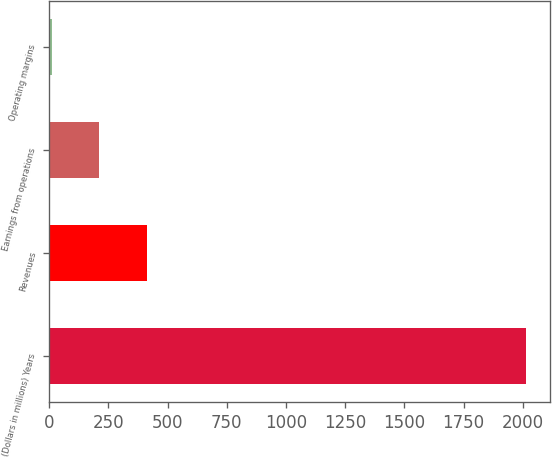<chart> <loc_0><loc_0><loc_500><loc_500><bar_chart><fcel>(Dollars in millions) Years<fcel>Revenues<fcel>Earnings from operations<fcel>Operating margins<nl><fcel>2015<fcel>413<fcel>212.3<fcel>12<nl></chart> 